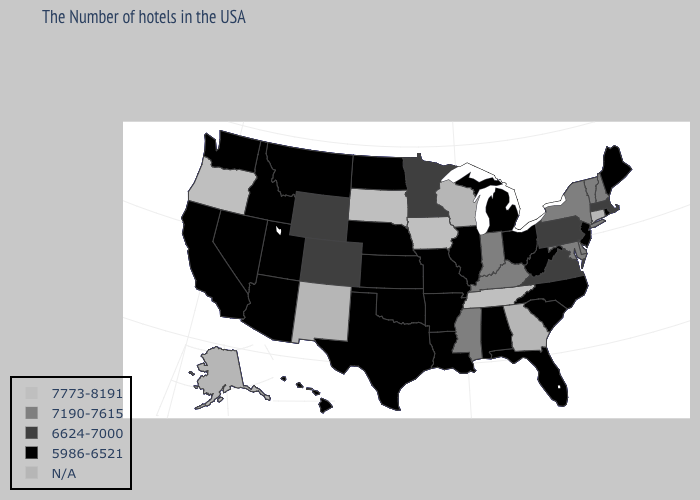Which states hav the highest value in the MidWest?
Quick response, please. Iowa, South Dakota. Name the states that have a value in the range N/A?
Quick response, please. Connecticut, Georgia, Wisconsin, New Mexico, Alaska. Name the states that have a value in the range 5986-6521?
Quick response, please. Maine, Rhode Island, New Jersey, North Carolina, South Carolina, West Virginia, Ohio, Florida, Michigan, Alabama, Illinois, Louisiana, Missouri, Arkansas, Kansas, Nebraska, Oklahoma, Texas, North Dakota, Utah, Montana, Arizona, Idaho, Nevada, California, Washington, Hawaii. What is the value of Illinois?
Quick response, please. 5986-6521. What is the lowest value in the Northeast?
Concise answer only. 5986-6521. How many symbols are there in the legend?
Keep it brief. 5. What is the lowest value in states that border South Dakota?
Quick response, please. 5986-6521. What is the value of Pennsylvania?
Keep it brief. 6624-7000. How many symbols are there in the legend?
Answer briefly. 5. Among the states that border Wyoming , which have the lowest value?
Give a very brief answer. Nebraska, Utah, Montana, Idaho. Name the states that have a value in the range 5986-6521?
Short answer required. Maine, Rhode Island, New Jersey, North Carolina, South Carolina, West Virginia, Ohio, Florida, Michigan, Alabama, Illinois, Louisiana, Missouri, Arkansas, Kansas, Nebraska, Oklahoma, Texas, North Dakota, Utah, Montana, Arizona, Idaho, Nevada, California, Washington, Hawaii. Among the states that border Michigan , which have the highest value?
Answer briefly. Indiana. Name the states that have a value in the range 7190-7615?
Give a very brief answer. New Hampshire, Vermont, New York, Delaware, Maryland, Kentucky, Indiana, Mississippi. Among the states that border North Carolina , does South Carolina have the lowest value?
Write a very short answer. Yes. 